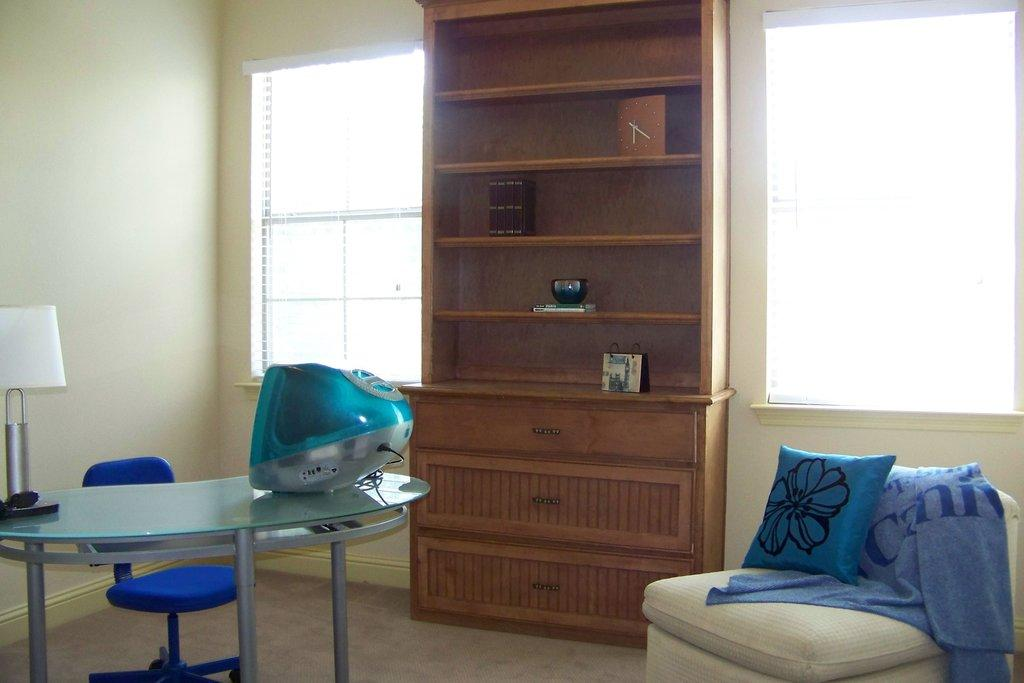What electronic device is on the table in the image? There is a television on the table in the image. What other object is on the table? There is a lamp on the table. What type of furniture is near the table? A chair is near the table. What type of seating is in the room? There is a sofa in the room. What is covering the sofa? There is cloth on the sofa. What type of storage is in the room? There is a shelf in the room. What allows natural light into the room? There are windows in the room. What is one of the main structural elements in the room? There is a wall in the room. What type of whip is being used to clean the windows in the image? There is no whip present in the image, and the windows are not being cleaned. How does the sun affect the lighting in the room in the image? The image does not provide information about the sun or its effect on the lighting in the room. 